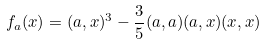Convert formula to latex. <formula><loc_0><loc_0><loc_500><loc_500>f _ { a } ( x ) = ( a , x ) ^ { 3 } - \frac { 3 } { 5 } ( a , a ) ( a , x ) ( x , x )</formula> 